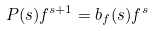Convert formula to latex. <formula><loc_0><loc_0><loc_500><loc_500>P ( s ) f ^ { s + 1 } = b _ { f } ( s ) f ^ { s }</formula> 